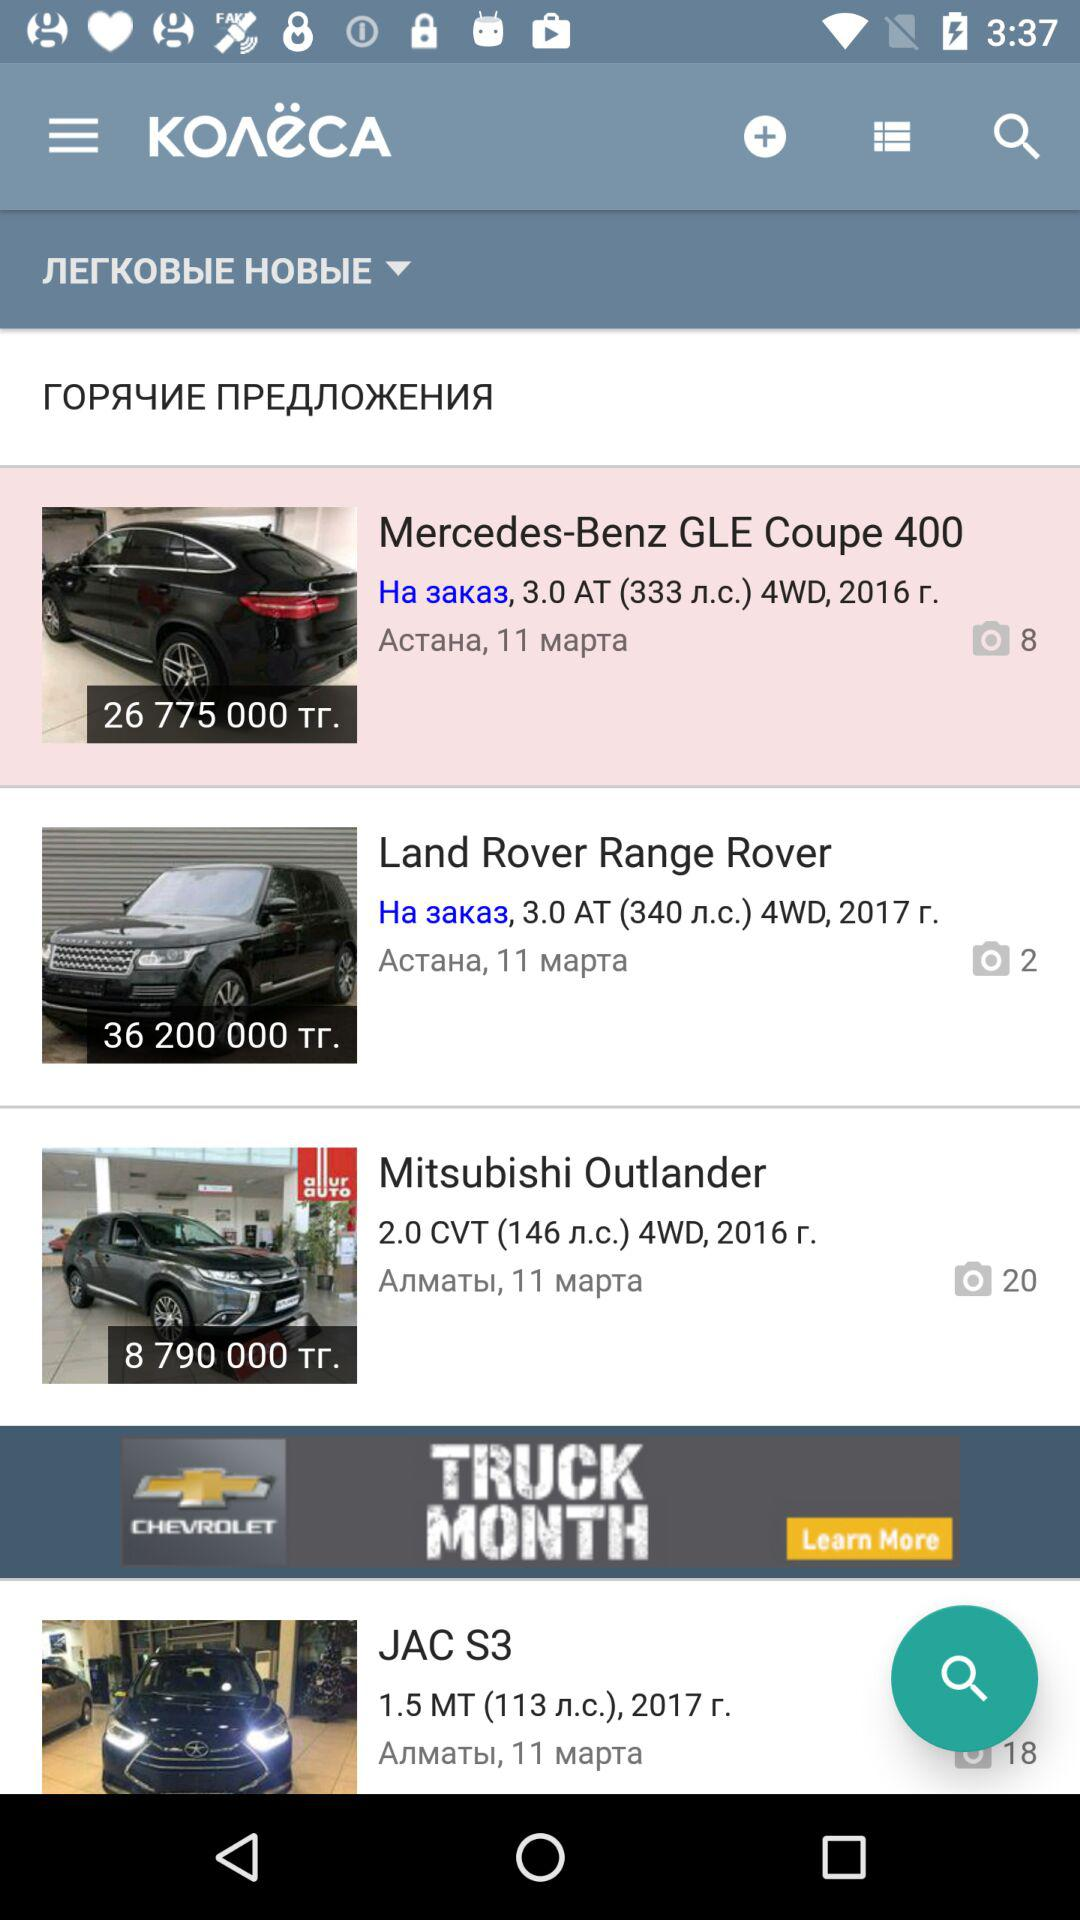What is the price of the Mercedes-Benz GLE Coupe 400? The price is 26775000 Tг. 